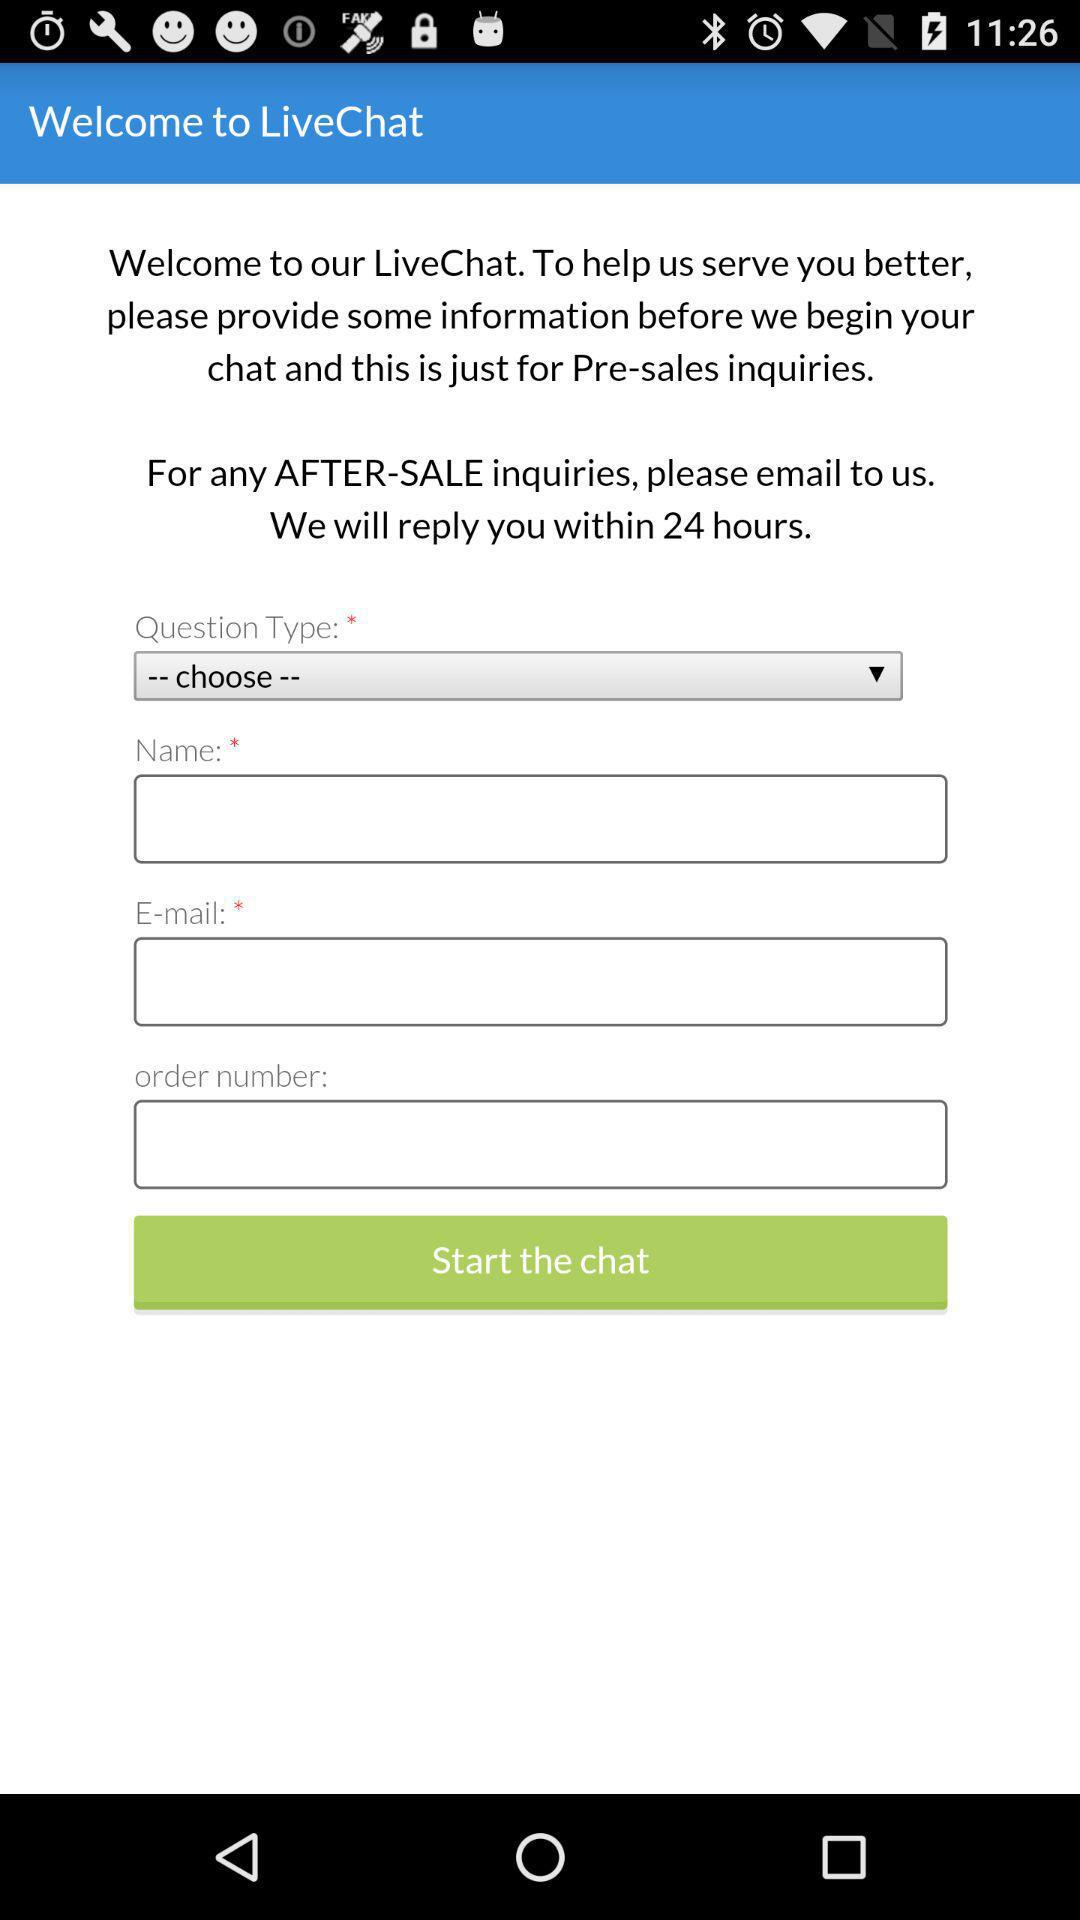What is the application name? The application name is "LiveChat". 